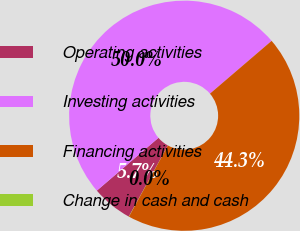<chart> <loc_0><loc_0><loc_500><loc_500><pie_chart><fcel>Operating activities<fcel>Investing activities<fcel>Financing activities<fcel>Change in cash and cash<nl><fcel>5.72%<fcel>50.0%<fcel>44.25%<fcel>0.02%<nl></chart> 